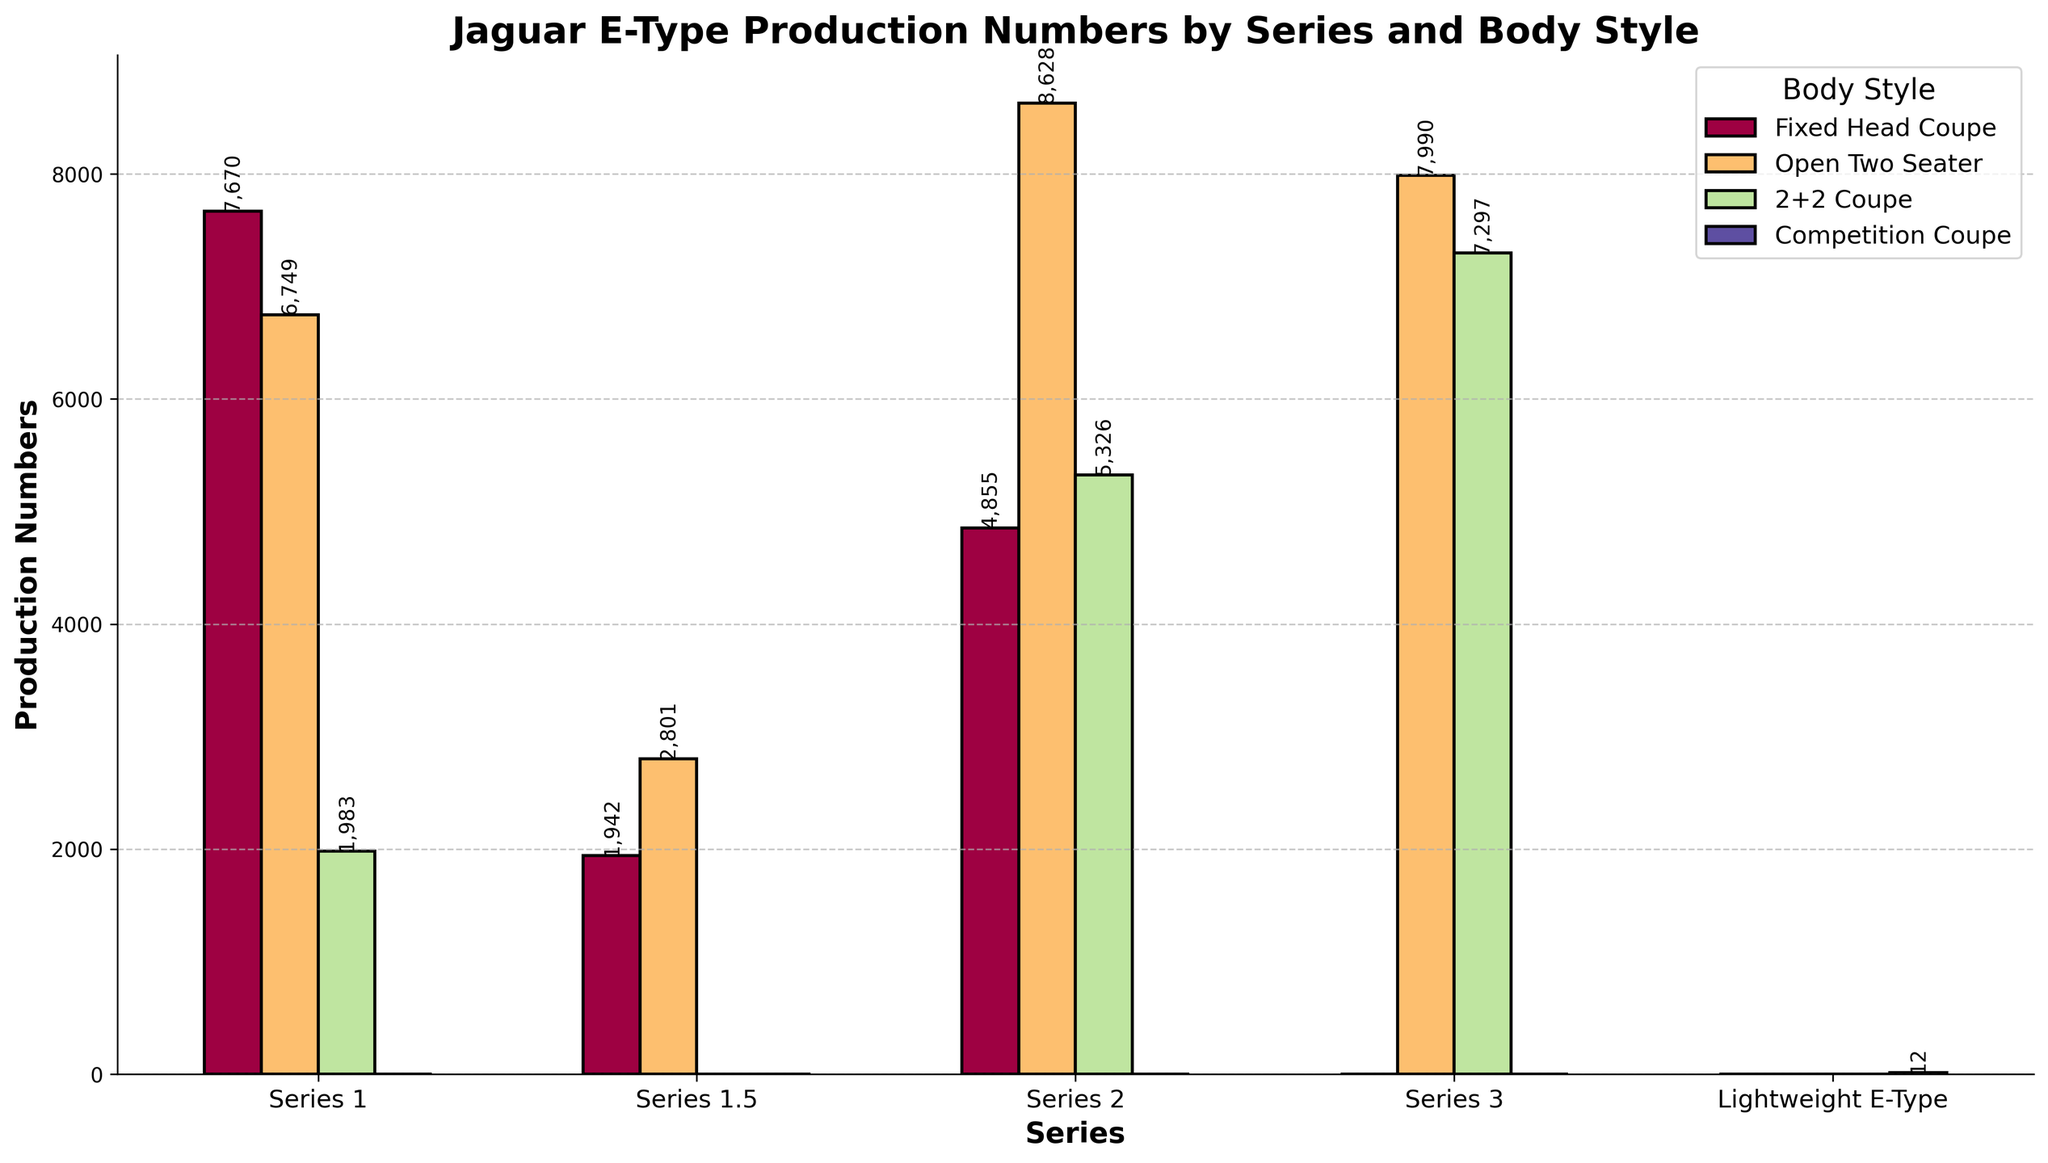What's the total production number for Series 1? To find the total production for Series 1, sum the production numbers of all body styles within Series 1: 7670 (Fixed Head Coupe) + 6749 (Open Two Seater) + 1983 (2+2 Coupe) = 16,402.
Answer: 16,402 Which body style has the highest production number in Series 2? Look at the heights of the bars for Series 2 and compare their values. The highest bar represents the Open Two Seater with 8628 units produced.
Answer: Open Two Seater How does the production number of the Series 3 Open Two Seater compare to the Series 2 Open Two Seater? Compare the heights of the bars for the Open Two Seater in Series 3 (7990) and Series 2 (8628). The Series 3 has fewer units compared to Series 2.
Answer: Series 3 has fewer units What is the production difference between Series 1 Fixed Head Coupe and Open Two Seater? Subtract the production number of Series 1 Open Two Seater from the Series 1 Fixed Head Coupe: 7670 - 6749 = 921.
Answer: 921 Which series had more 2+2 Coupe units produced, Series 1 or Series 2? Compare the bar heights for the 2+2 Coupe in Series 1 (1983) and Series 2 (5326). Series 2 has more units produced.
Answer: Series 2 How many more units were produced of the Series 2 2+2 Coupe compared to the Series 1 2+2 Coupe? Subtract the production number of Series 1 2+2 Coupe from Series 2 2+2 Coupe: 5326 - 1983 = 3343.
Answer: 3343 What’s the total production number for all Series 3 body styles combined? Add the production numbers of all body styles for Series 3: 7990 (Open Two Seater) + 7297 (2+2 Coupe) = 15,287.
Answer: 15,287 What is unique about the Lightweight E-Type when compared to all other series? By visual inspection, the Lightweight E-Type's production number is far lower with only 12 units, compared to thousands for the other series.
Answer: Extremely low production Which series has a greater total production number, Series 1 or Series 2? Calculate the total production for each and compare: Series 1 (16,402) vs. Series 2 (18809). Series 2 has a higher total.
Answer: Series 2 What is the average production number for the Fixed Head Coupe across all series? Add the production numbers of Fixed Head Coupe in all series and divide by the number of series with this body style: (7670 + 1942 + 4855) / 3 = 14,467 / 3 ≈ 4822.33.
Answer: ~4822.33 